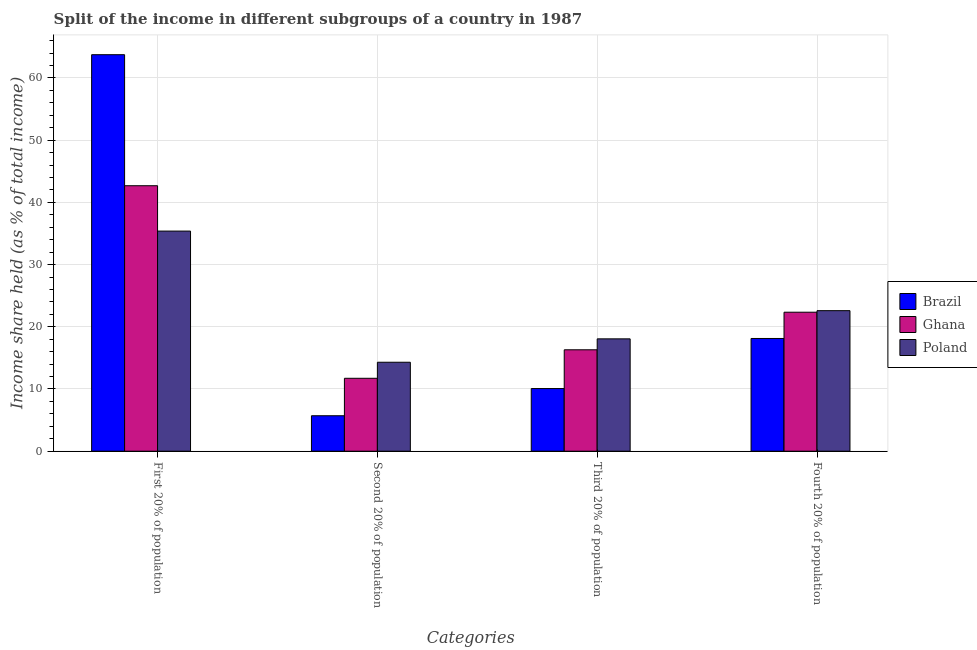How many different coloured bars are there?
Give a very brief answer. 3. How many groups of bars are there?
Provide a succinct answer. 4. Are the number of bars per tick equal to the number of legend labels?
Offer a very short reply. Yes. Are the number of bars on each tick of the X-axis equal?
Your response must be concise. Yes. How many bars are there on the 1st tick from the right?
Ensure brevity in your answer.  3. What is the label of the 1st group of bars from the left?
Provide a succinct answer. First 20% of population. What is the share of the income held by first 20% of the population in Brazil?
Provide a short and direct response. 63.73. Across all countries, what is the maximum share of the income held by third 20% of the population?
Keep it short and to the point. 18.06. Across all countries, what is the minimum share of the income held by second 20% of the population?
Ensure brevity in your answer.  5.7. What is the total share of the income held by first 20% of the population in the graph?
Your response must be concise. 141.78. What is the difference between the share of the income held by third 20% of the population in Brazil and that in Ghana?
Provide a short and direct response. -6.23. What is the difference between the share of the income held by first 20% of the population in Ghana and the share of the income held by second 20% of the population in Brazil?
Keep it short and to the point. 36.97. What is the average share of the income held by second 20% of the population per country?
Ensure brevity in your answer.  10.57. What is the difference between the share of the income held by third 20% of the population and share of the income held by first 20% of the population in Poland?
Ensure brevity in your answer.  -17.32. What is the ratio of the share of the income held by second 20% of the population in Ghana to that in Poland?
Your answer should be very brief. 0.82. Is the difference between the share of the income held by second 20% of the population in Brazil and Poland greater than the difference between the share of the income held by third 20% of the population in Brazil and Poland?
Ensure brevity in your answer.  No. What is the difference between the highest and the second highest share of the income held by first 20% of the population?
Ensure brevity in your answer.  21.06. What is the difference between the highest and the lowest share of the income held by fourth 20% of the population?
Make the answer very short. 4.47. Is the sum of the share of the income held by second 20% of the population in Poland and Ghana greater than the maximum share of the income held by third 20% of the population across all countries?
Your response must be concise. Yes. Is it the case that in every country, the sum of the share of the income held by third 20% of the population and share of the income held by fourth 20% of the population is greater than the sum of share of the income held by first 20% of the population and share of the income held by second 20% of the population?
Give a very brief answer. Yes. What does the 2nd bar from the left in Second 20% of population represents?
Your answer should be very brief. Ghana. What does the 3rd bar from the right in Third 20% of population represents?
Your answer should be compact. Brazil. How many bars are there?
Keep it short and to the point. 12. Are all the bars in the graph horizontal?
Provide a succinct answer. No. What is the title of the graph?
Make the answer very short. Split of the income in different subgroups of a country in 1987. What is the label or title of the X-axis?
Provide a succinct answer. Categories. What is the label or title of the Y-axis?
Make the answer very short. Income share held (as % of total income). What is the Income share held (as % of total income) of Brazil in First 20% of population?
Your answer should be very brief. 63.73. What is the Income share held (as % of total income) of Ghana in First 20% of population?
Make the answer very short. 42.67. What is the Income share held (as % of total income) in Poland in First 20% of population?
Your answer should be compact. 35.38. What is the Income share held (as % of total income) of Ghana in Second 20% of population?
Keep it short and to the point. 11.72. What is the Income share held (as % of total income) of Poland in Second 20% of population?
Make the answer very short. 14.3. What is the Income share held (as % of total income) of Brazil in Third 20% of population?
Offer a very short reply. 10.07. What is the Income share held (as % of total income) in Poland in Third 20% of population?
Make the answer very short. 18.06. What is the Income share held (as % of total income) in Brazil in Fourth 20% of population?
Your answer should be compact. 18.12. What is the Income share held (as % of total income) in Ghana in Fourth 20% of population?
Provide a succinct answer. 22.34. What is the Income share held (as % of total income) of Poland in Fourth 20% of population?
Keep it short and to the point. 22.59. Across all Categories, what is the maximum Income share held (as % of total income) of Brazil?
Your answer should be very brief. 63.73. Across all Categories, what is the maximum Income share held (as % of total income) in Ghana?
Offer a terse response. 42.67. Across all Categories, what is the maximum Income share held (as % of total income) in Poland?
Provide a short and direct response. 35.38. Across all Categories, what is the minimum Income share held (as % of total income) of Brazil?
Your answer should be compact. 5.7. Across all Categories, what is the minimum Income share held (as % of total income) of Ghana?
Provide a short and direct response. 11.72. What is the total Income share held (as % of total income) of Brazil in the graph?
Give a very brief answer. 97.62. What is the total Income share held (as % of total income) in Ghana in the graph?
Offer a terse response. 93.03. What is the total Income share held (as % of total income) in Poland in the graph?
Make the answer very short. 90.33. What is the difference between the Income share held (as % of total income) of Brazil in First 20% of population and that in Second 20% of population?
Provide a succinct answer. 58.03. What is the difference between the Income share held (as % of total income) in Ghana in First 20% of population and that in Second 20% of population?
Give a very brief answer. 30.95. What is the difference between the Income share held (as % of total income) of Poland in First 20% of population and that in Second 20% of population?
Your response must be concise. 21.08. What is the difference between the Income share held (as % of total income) of Brazil in First 20% of population and that in Third 20% of population?
Your answer should be compact. 53.66. What is the difference between the Income share held (as % of total income) of Ghana in First 20% of population and that in Third 20% of population?
Keep it short and to the point. 26.37. What is the difference between the Income share held (as % of total income) of Poland in First 20% of population and that in Third 20% of population?
Provide a succinct answer. 17.32. What is the difference between the Income share held (as % of total income) in Brazil in First 20% of population and that in Fourth 20% of population?
Ensure brevity in your answer.  45.61. What is the difference between the Income share held (as % of total income) of Ghana in First 20% of population and that in Fourth 20% of population?
Provide a short and direct response. 20.33. What is the difference between the Income share held (as % of total income) in Poland in First 20% of population and that in Fourth 20% of population?
Provide a succinct answer. 12.79. What is the difference between the Income share held (as % of total income) of Brazil in Second 20% of population and that in Third 20% of population?
Offer a terse response. -4.37. What is the difference between the Income share held (as % of total income) in Ghana in Second 20% of population and that in Third 20% of population?
Your answer should be compact. -4.58. What is the difference between the Income share held (as % of total income) of Poland in Second 20% of population and that in Third 20% of population?
Make the answer very short. -3.76. What is the difference between the Income share held (as % of total income) in Brazil in Second 20% of population and that in Fourth 20% of population?
Give a very brief answer. -12.42. What is the difference between the Income share held (as % of total income) of Ghana in Second 20% of population and that in Fourth 20% of population?
Give a very brief answer. -10.62. What is the difference between the Income share held (as % of total income) in Poland in Second 20% of population and that in Fourth 20% of population?
Offer a very short reply. -8.29. What is the difference between the Income share held (as % of total income) in Brazil in Third 20% of population and that in Fourth 20% of population?
Offer a very short reply. -8.05. What is the difference between the Income share held (as % of total income) in Ghana in Third 20% of population and that in Fourth 20% of population?
Make the answer very short. -6.04. What is the difference between the Income share held (as % of total income) of Poland in Third 20% of population and that in Fourth 20% of population?
Provide a short and direct response. -4.53. What is the difference between the Income share held (as % of total income) in Brazil in First 20% of population and the Income share held (as % of total income) in Ghana in Second 20% of population?
Offer a terse response. 52.01. What is the difference between the Income share held (as % of total income) in Brazil in First 20% of population and the Income share held (as % of total income) in Poland in Second 20% of population?
Provide a short and direct response. 49.43. What is the difference between the Income share held (as % of total income) in Ghana in First 20% of population and the Income share held (as % of total income) in Poland in Second 20% of population?
Ensure brevity in your answer.  28.37. What is the difference between the Income share held (as % of total income) in Brazil in First 20% of population and the Income share held (as % of total income) in Ghana in Third 20% of population?
Provide a succinct answer. 47.43. What is the difference between the Income share held (as % of total income) of Brazil in First 20% of population and the Income share held (as % of total income) of Poland in Third 20% of population?
Your answer should be very brief. 45.67. What is the difference between the Income share held (as % of total income) in Ghana in First 20% of population and the Income share held (as % of total income) in Poland in Third 20% of population?
Your response must be concise. 24.61. What is the difference between the Income share held (as % of total income) of Brazil in First 20% of population and the Income share held (as % of total income) of Ghana in Fourth 20% of population?
Offer a very short reply. 41.39. What is the difference between the Income share held (as % of total income) of Brazil in First 20% of population and the Income share held (as % of total income) of Poland in Fourth 20% of population?
Your answer should be very brief. 41.14. What is the difference between the Income share held (as % of total income) in Ghana in First 20% of population and the Income share held (as % of total income) in Poland in Fourth 20% of population?
Your response must be concise. 20.08. What is the difference between the Income share held (as % of total income) in Brazil in Second 20% of population and the Income share held (as % of total income) in Ghana in Third 20% of population?
Provide a succinct answer. -10.6. What is the difference between the Income share held (as % of total income) in Brazil in Second 20% of population and the Income share held (as % of total income) in Poland in Third 20% of population?
Make the answer very short. -12.36. What is the difference between the Income share held (as % of total income) of Ghana in Second 20% of population and the Income share held (as % of total income) of Poland in Third 20% of population?
Offer a very short reply. -6.34. What is the difference between the Income share held (as % of total income) in Brazil in Second 20% of population and the Income share held (as % of total income) in Ghana in Fourth 20% of population?
Your answer should be compact. -16.64. What is the difference between the Income share held (as % of total income) in Brazil in Second 20% of population and the Income share held (as % of total income) in Poland in Fourth 20% of population?
Make the answer very short. -16.89. What is the difference between the Income share held (as % of total income) in Ghana in Second 20% of population and the Income share held (as % of total income) in Poland in Fourth 20% of population?
Provide a succinct answer. -10.87. What is the difference between the Income share held (as % of total income) of Brazil in Third 20% of population and the Income share held (as % of total income) of Ghana in Fourth 20% of population?
Provide a succinct answer. -12.27. What is the difference between the Income share held (as % of total income) of Brazil in Third 20% of population and the Income share held (as % of total income) of Poland in Fourth 20% of population?
Provide a succinct answer. -12.52. What is the difference between the Income share held (as % of total income) of Ghana in Third 20% of population and the Income share held (as % of total income) of Poland in Fourth 20% of population?
Your answer should be very brief. -6.29. What is the average Income share held (as % of total income) in Brazil per Categories?
Make the answer very short. 24.41. What is the average Income share held (as % of total income) in Ghana per Categories?
Your answer should be compact. 23.26. What is the average Income share held (as % of total income) of Poland per Categories?
Your response must be concise. 22.58. What is the difference between the Income share held (as % of total income) in Brazil and Income share held (as % of total income) in Ghana in First 20% of population?
Your answer should be compact. 21.06. What is the difference between the Income share held (as % of total income) of Brazil and Income share held (as % of total income) of Poland in First 20% of population?
Keep it short and to the point. 28.35. What is the difference between the Income share held (as % of total income) of Ghana and Income share held (as % of total income) of Poland in First 20% of population?
Offer a terse response. 7.29. What is the difference between the Income share held (as % of total income) of Brazil and Income share held (as % of total income) of Ghana in Second 20% of population?
Provide a succinct answer. -6.02. What is the difference between the Income share held (as % of total income) of Ghana and Income share held (as % of total income) of Poland in Second 20% of population?
Make the answer very short. -2.58. What is the difference between the Income share held (as % of total income) in Brazil and Income share held (as % of total income) in Ghana in Third 20% of population?
Ensure brevity in your answer.  -6.23. What is the difference between the Income share held (as % of total income) in Brazil and Income share held (as % of total income) in Poland in Third 20% of population?
Give a very brief answer. -7.99. What is the difference between the Income share held (as % of total income) in Ghana and Income share held (as % of total income) in Poland in Third 20% of population?
Ensure brevity in your answer.  -1.76. What is the difference between the Income share held (as % of total income) in Brazil and Income share held (as % of total income) in Ghana in Fourth 20% of population?
Give a very brief answer. -4.22. What is the difference between the Income share held (as % of total income) in Brazil and Income share held (as % of total income) in Poland in Fourth 20% of population?
Give a very brief answer. -4.47. What is the ratio of the Income share held (as % of total income) in Brazil in First 20% of population to that in Second 20% of population?
Offer a terse response. 11.18. What is the ratio of the Income share held (as % of total income) of Ghana in First 20% of population to that in Second 20% of population?
Make the answer very short. 3.64. What is the ratio of the Income share held (as % of total income) in Poland in First 20% of population to that in Second 20% of population?
Your answer should be very brief. 2.47. What is the ratio of the Income share held (as % of total income) in Brazil in First 20% of population to that in Third 20% of population?
Your answer should be compact. 6.33. What is the ratio of the Income share held (as % of total income) of Ghana in First 20% of population to that in Third 20% of population?
Keep it short and to the point. 2.62. What is the ratio of the Income share held (as % of total income) of Poland in First 20% of population to that in Third 20% of population?
Your response must be concise. 1.96. What is the ratio of the Income share held (as % of total income) of Brazil in First 20% of population to that in Fourth 20% of population?
Keep it short and to the point. 3.52. What is the ratio of the Income share held (as % of total income) of Ghana in First 20% of population to that in Fourth 20% of population?
Provide a short and direct response. 1.91. What is the ratio of the Income share held (as % of total income) in Poland in First 20% of population to that in Fourth 20% of population?
Make the answer very short. 1.57. What is the ratio of the Income share held (as % of total income) in Brazil in Second 20% of population to that in Third 20% of population?
Offer a very short reply. 0.57. What is the ratio of the Income share held (as % of total income) of Ghana in Second 20% of population to that in Third 20% of population?
Give a very brief answer. 0.72. What is the ratio of the Income share held (as % of total income) of Poland in Second 20% of population to that in Third 20% of population?
Offer a very short reply. 0.79. What is the ratio of the Income share held (as % of total income) of Brazil in Second 20% of population to that in Fourth 20% of population?
Provide a succinct answer. 0.31. What is the ratio of the Income share held (as % of total income) of Ghana in Second 20% of population to that in Fourth 20% of population?
Offer a very short reply. 0.52. What is the ratio of the Income share held (as % of total income) in Poland in Second 20% of population to that in Fourth 20% of population?
Keep it short and to the point. 0.63. What is the ratio of the Income share held (as % of total income) of Brazil in Third 20% of population to that in Fourth 20% of population?
Provide a succinct answer. 0.56. What is the ratio of the Income share held (as % of total income) in Ghana in Third 20% of population to that in Fourth 20% of population?
Offer a very short reply. 0.73. What is the ratio of the Income share held (as % of total income) in Poland in Third 20% of population to that in Fourth 20% of population?
Offer a terse response. 0.8. What is the difference between the highest and the second highest Income share held (as % of total income) of Brazil?
Offer a very short reply. 45.61. What is the difference between the highest and the second highest Income share held (as % of total income) of Ghana?
Your answer should be very brief. 20.33. What is the difference between the highest and the second highest Income share held (as % of total income) in Poland?
Offer a terse response. 12.79. What is the difference between the highest and the lowest Income share held (as % of total income) of Brazil?
Offer a very short reply. 58.03. What is the difference between the highest and the lowest Income share held (as % of total income) of Ghana?
Give a very brief answer. 30.95. What is the difference between the highest and the lowest Income share held (as % of total income) of Poland?
Offer a terse response. 21.08. 